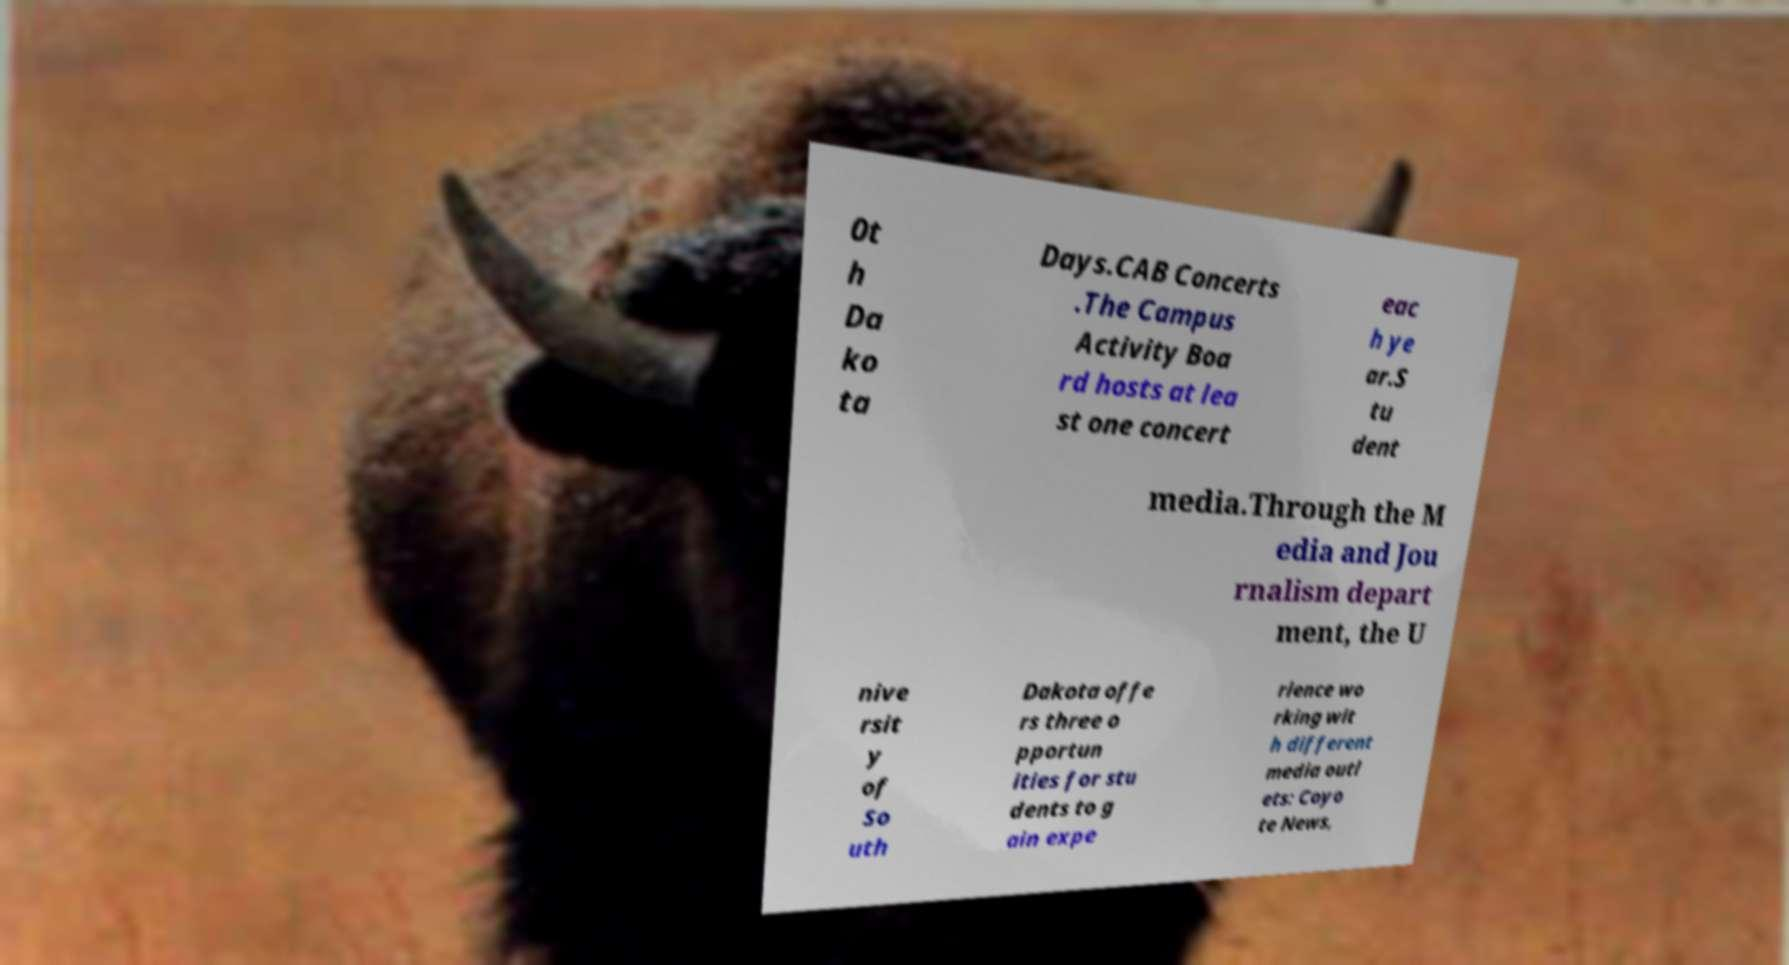Can you read and provide the text displayed in the image?This photo seems to have some interesting text. Can you extract and type it out for me? 0t h Da ko ta Days.CAB Concerts .The Campus Activity Boa rd hosts at lea st one concert eac h ye ar.S tu dent media.Through the M edia and Jou rnalism depart ment, the U nive rsit y of So uth Dakota offe rs three o pportun ities for stu dents to g ain expe rience wo rking wit h different media outl ets: Coyo te News, 